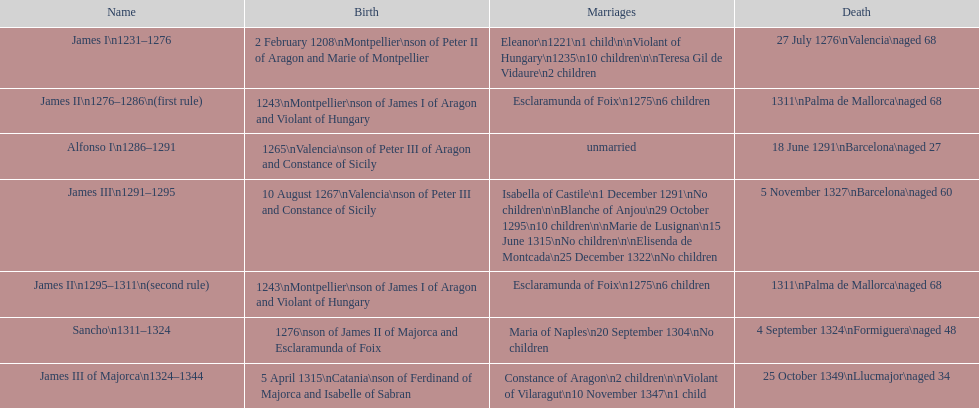Give me the full table as a dictionary. {'header': ['Name', 'Birth', 'Marriages', 'Death'], 'rows': [['James I\\n1231–1276', '2 February 1208\\nMontpellier\\nson of Peter II of Aragon and Marie of Montpellier', 'Eleanor\\n1221\\n1 child\\n\\nViolant of Hungary\\n1235\\n10 children\\n\\nTeresa Gil de Vidaure\\n2 children', '27 July 1276\\nValencia\\naged 68'], ['James II\\n1276–1286\\n(first rule)', '1243\\nMontpellier\\nson of James I of Aragon and Violant of Hungary', 'Esclaramunda of Foix\\n1275\\n6 children', '1311\\nPalma de Mallorca\\naged 68'], ['Alfonso I\\n1286–1291', '1265\\nValencia\\nson of Peter III of Aragon and Constance of Sicily', 'unmarried', '18 June 1291\\nBarcelona\\naged 27'], ['James III\\n1291–1295', '10 August 1267\\nValencia\\nson of Peter III and Constance of Sicily', 'Isabella of Castile\\n1 December 1291\\nNo children\\n\\nBlanche of Anjou\\n29 October 1295\\n10 children\\n\\nMarie de Lusignan\\n15 June 1315\\nNo children\\n\\nElisenda de Montcada\\n25 December 1322\\nNo children', '5 November 1327\\nBarcelona\\naged 60'], ['James II\\n1295–1311\\n(second rule)', '1243\\nMontpellier\\nson of James I of Aragon and Violant of Hungary', 'Esclaramunda of Foix\\n1275\\n6 children', '1311\\nPalma de Mallorca\\naged 68'], ['Sancho\\n1311–1324', '1276\\nson of James II of Majorca and Esclaramunda of Foix', 'Maria of Naples\\n20 September 1304\\nNo children', '4 September 1324\\nFormiguera\\naged 48'], ['James III of Majorca\\n1324–1344', '5 April 1315\\nCatania\\nson of Ferdinand of Majorca and Isabelle of Sabran', 'Constance of Aragon\\n2 children\\n\\nViolant of Vilaragut\\n10 November 1347\\n1 child', '25 October 1349\\nLlucmajor\\naged 34']]} Who came to power after the rule of james iii? James II. 